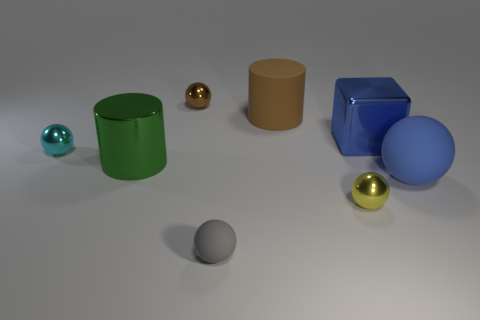Do the shadows tell us anything about the light source? Yes, the shadows in the image provide clues about the light source. The shadows cast by the objects are soft-edged and fall primarily to the right of the objects, indicating that the light source is to the left of the frame. This suggests soft and diffused lighting, like that from an overcast sky or a softbox used in photography. The lack of sharp shadows also implies that the light source is not extremely close to the objects. 